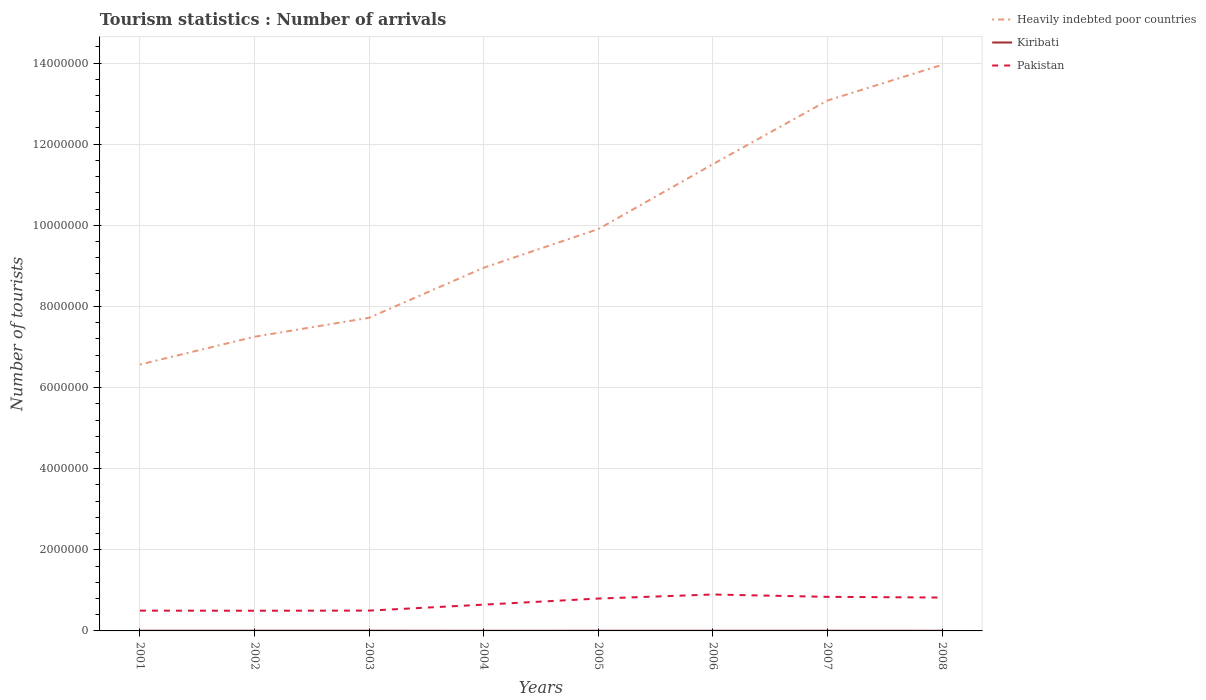How many different coloured lines are there?
Provide a succinct answer. 3. Does the line corresponding to Heavily indebted poor countries intersect with the line corresponding to Kiribati?
Offer a terse response. No. Is the number of lines equal to the number of legend labels?
Provide a short and direct response. Yes. Across all years, what is the maximum number of tourist arrivals in Kiribati?
Your answer should be very brief. 3400. What is the total number of tourist arrivals in Pakistan in the graph?
Your answer should be very brief. -1000. What is the difference between the highest and the second highest number of tourist arrivals in Heavily indebted poor countries?
Provide a short and direct response. 7.39e+06. What is the difference between the highest and the lowest number of tourist arrivals in Kiribati?
Provide a short and direct response. 5. Is the number of tourist arrivals in Kiribati strictly greater than the number of tourist arrivals in Pakistan over the years?
Keep it short and to the point. Yes. How many years are there in the graph?
Give a very brief answer. 8. Are the values on the major ticks of Y-axis written in scientific E-notation?
Your answer should be compact. No. Does the graph contain any zero values?
Offer a terse response. No. How many legend labels are there?
Your response must be concise. 3. How are the legend labels stacked?
Provide a short and direct response. Vertical. What is the title of the graph?
Your response must be concise. Tourism statistics : Number of arrivals. What is the label or title of the Y-axis?
Provide a succinct answer. Number of tourists. What is the Number of tourists of Heavily indebted poor countries in 2001?
Offer a terse response. 6.57e+06. What is the Number of tourists in Kiribati in 2001?
Your response must be concise. 4600. What is the Number of tourists of Pakistan in 2001?
Offer a terse response. 5.00e+05. What is the Number of tourists of Heavily indebted poor countries in 2002?
Keep it short and to the point. 7.25e+06. What is the Number of tourists of Kiribati in 2002?
Provide a short and direct response. 4900. What is the Number of tourists in Pakistan in 2002?
Offer a terse response. 4.98e+05. What is the Number of tourists of Heavily indebted poor countries in 2003?
Offer a very short reply. 7.72e+06. What is the Number of tourists in Kiribati in 2003?
Keep it short and to the point. 4900. What is the Number of tourists of Pakistan in 2003?
Provide a succinct answer. 5.01e+05. What is the Number of tourists in Heavily indebted poor countries in 2004?
Provide a succinct answer. 8.95e+06. What is the Number of tourists in Kiribati in 2004?
Keep it short and to the point. 3400. What is the Number of tourists in Pakistan in 2004?
Offer a very short reply. 6.48e+05. What is the Number of tourists in Heavily indebted poor countries in 2005?
Your answer should be very brief. 9.91e+06. What is the Number of tourists in Kiribati in 2005?
Make the answer very short. 4100. What is the Number of tourists in Pakistan in 2005?
Give a very brief answer. 7.98e+05. What is the Number of tourists of Heavily indebted poor countries in 2006?
Offer a very short reply. 1.15e+07. What is the Number of tourists of Kiribati in 2006?
Your answer should be very brief. 4400. What is the Number of tourists of Pakistan in 2006?
Give a very brief answer. 8.98e+05. What is the Number of tourists in Heavily indebted poor countries in 2007?
Offer a terse response. 1.31e+07. What is the Number of tourists in Kiribati in 2007?
Offer a terse response. 4700. What is the Number of tourists of Pakistan in 2007?
Ensure brevity in your answer.  8.40e+05. What is the Number of tourists in Heavily indebted poor countries in 2008?
Keep it short and to the point. 1.40e+07. What is the Number of tourists of Kiribati in 2008?
Offer a very short reply. 3900. What is the Number of tourists of Pakistan in 2008?
Provide a succinct answer. 8.23e+05. Across all years, what is the maximum Number of tourists of Heavily indebted poor countries?
Your answer should be compact. 1.40e+07. Across all years, what is the maximum Number of tourists of Kiribati?
Give a very brief answer. 4900. Across all years, what is the maximum Number of tourists of Pakistan?
Give a very brief answer. 8.98e+05. Across all years, what is the minimum Number of tourists of Heavily indebted poor countries?
Your answer should be very brief. 6.57e+06. Across all years, what is the minimum Number of tourists in Kiribati?
Provide a short and direct response. 3400. Across all years, what is the minimum Number of tourists of Pakistan?
Your answer should be very brief. 4.98e+05. What is the total Number of tourists in Heavily indebted poor countries in the graph?
Provide a short and direct response. 7.89e+07. What is the total Number of tourists in Kiribati in the graph?
Make the answer very short. 3.49e+04. What is the total Number of tourists in Pakistan in the graph?
Your answer should be compact. 5.51e+06. What is the difference between the Number of tourists in Heavily indebted poor countries in 2001 and that in 2002?
Provide a succinct answer. -6.84e+05. What is the difference between the Number of tourists of Kiribati in 2001 and that in 2002?
Offer a terse response. -300. What is the difference between the Number of tourists in Pakistan in 2001 and that in 2002?
Ensure brevity in your answer.  2000. What is the difference between the Number of tourists in Heavily indebted poor countries in 2001 and that in 2003?
Your answer should be very brief. -1.15e+06. What is the difference between the Number of tourists of Kiribati in 2001 and that in 2003?
Ensure brevity in your answer.  -300. What is the difference between the Number of tourists of Pakistan in 2001 and that in 2003?
Your answer should be compact. -1000. What is the difference between the Number of tourists of Heavily indebted poor countries in 2001 and that in 2004?
Give a very brief answer. -2.39e+06. What is the difference between the Number of tourists of Kiribati in 2001 and that in 2004?
Give a very brief answer. 1200. What is the difference between the Number of tourists in Pakistan in 2001 and that in 2004?
Provide a short and direct response. -1.48e+05. What is the difference between the Number of tourists in Heavily indebted poor countries in 2001 and that in 2005?
Make the answer very short. -3.34e+06. What is the difference between the Number of tourists in Pakistan in 2001 and that in 2005?
Your response must be concise. -2.98e+05. What is the difference between the Number of tourists of Heavily indebted poor countries in 2001 and that in 2006?
Your answer should be compact. -4.94e+06. What is the difference between the Number of tourists in Kiribati in 2001 and that in 2006?
Provide a succinct answer. 200. What is the difference between the Number of tourists in Pakistan in 2001 and that in 2006?
Your answer should be very brief. -3.98e+05. What is the difference between the Number of tourists of Heavily indebted poor countries in 2001 and that in 2007?
Keep it short and to the point. -6.51e+06. What is the difference between the Number of tourists in Kiribati in 2001 and that in 2007?
Provide a short and direct response. -100. What is the difference between the Number of tourists in Heavily indebted poor countries in 2001 and that in 2008?
Offer a terse response. -7.39e+06. What is the difference between the Number of tourists of Kiribati in 2001 and that in 2008?
Provide a short and direct response. 700. What is the difference between the Number of tourists of Pakistan in 2001 and that in 2008?
Give a very brief answer. -3.23e+05. What is the difference between the Number of tourists of Heavily indebted poor countries in 2002 and that in 2003?
Give a very brief answer. -4.68e+05. What is the difference between the Number of tourists of Pakistan in 2002 and that in 2003?
Your answer should be very brief. -3000. What is the difference between the Number of tourists in Heavily indebted poor countries in 2002 and that in 2004?
Make the answer very short. -1.70e+06. What is the difference between the Number of tourists in Kiribati in 2002 and that in 2004?
Offer a terse response. 1500. What is the difference between the Number of tourists of Heavily indebted poor countries in 2002 and that in 2005?
Make the answer very short. -2.65e+06. What is the difference between the Number of tourists in Kiribati in 2002 and that in 2005?
Your answer should be very brief. 800. What is the difference between the Number of tourists in Pakistan in 2002 and that in 2005?
Your response must be concise. -3.00e+05. What is the difference between the Number of tourists of Heavily indebted poor countries in 2002 and that in 2006?
Offer a terse response. -4.25e+06. What is the difference between the Number of tourists of Kiribati in 2002 and that in 2006?
Give a very brief answer. 500. What is the difference between the Number of tourists of Pakistan in 2002 and that in 2006?
Provide a succinct answer. -4.00e+05. What is the difference between the Number of tourists in Heavily indebted poor countries in 2002 and that in 2007?
Your answer should be compact. -5.82e+06. What is the difference between the Number of tourists of Pakistan in 2002 and that in 2007?
Give a very brief answer. -3.42e+05. What is the difference between the Number of tourists in Heavily indebted poor countries in 2002 and that in 2008?
Your answer should be compact. -6.70e+06. What is the difference between the Number of tourists in Kiribati in 2002 and that in 2008?
Keep it short and to the point. 1000. What is the difference between the Number of tourists of Pakistan in 2002 and that in 2008?
Offer a terse response. -3.25e+05. What is the difference between the Number of tourists in Heavily indebted poor countries in 2003 and that in 2004?
Offer a terse response. -1.23e+06. What is the difference between the Number of tourists in Kiribati in 2003 and that in 2004?
Offer a terse response. 1500. What is the difference between the Number of tourists of Pakistan in 2003 and that in 2004?
Provide a succinct answer. -1.47e+05. What is the difference between the Number of tourists of Heavily indebted poor countries in 2003 and that in 2005?
Ensure brevity in your answer.  -2.19e+06. What is the difference between the Number of tourists of Kiribati in 2003 and that in 2005?
Offer a terse response. 800. What is the difference between the Number of tourists of Pakistan in 2003 and that in 2005?
Provide a succinct answer. -2.97e+05. What is the difference between the Number of tourists in Heavily indebted poor countries in 2003 and that in 2006?
Make the answer very short. -3.79e+06. What is the difference between the Number of tourists of Kiribati in 2003 and that in 2006?
Your answer should be compact. 500. What is the difference between the Number of tourists of Pakistan in 2003 and that in 2006?
Provide a short and direct response. -3.97e+05. What is the difference between the Number of tourists in Heavily indebted poor countries in 2003 and that in 2007?
Provide a succinct answer. -5.36e+06. What is the difference between the Number of tourists in Pakistan in 2003 and that in 2007?
Your answer should be very brief. -3.39e+05. What is the difference between the Number of tourists in Heavily indebted poor countries in 2003 and that in 2008?
Ensure brevity in your answer.  -6.23e+06. What is the difference between the Number of tourists in Kiribati in 2003 and that in 2008?
Give a very brief answer. 1000. What is the difference between the Number of tourists in Pakistan in 2003 and that in 2008?
Ensure brevity in your answer.  -3.22e+05. What is the difference between the Number of tourists in Heavily indebted poor countries in 2004 and that in 2005?
Offer a very short reply. -9.53e+05. What is the difference between the Number of tourists of Kiribati in 2004 and that in 2005?
Offer a very short reply. -700. What is the difference between the Number of tourists in Pakistan in 2004 and that in 2005?
Give a very brief answer. -1.50e+05. What is the difference between the Number of tourists of Heavily indebted poor countries in 2004 and that in 2006?
Your response must be concise. -2.55e+06. What is the difference between the Number of tourists of Kiribati in 2004 and that in 2006?
Keep it short and to the point. -1000. What is the difference between the Number of tourists of Heavily indebted poor countries in 2004 and that in 2007?
Your answer should be very brief. -4.12e+06. What is the difference between the Number of tourists of Kiribati in 2004 and that in 2007?
Provide a succinct answer. -1300. What is the difference between the Number of tourists in Pakistan in 2004 and that in 2007?
Your response must be concise. -1.92e+05. What is the difference between the Number of tourists in Heavily indebted poor countries in 2004 and that in 2008?
Your response must be concise. -5.00e+06. What is the difference between the Number of tourists of Kiribati in 2004 and that in 2008?
Ensure brevity in your answer.  -500. What is the difference between the Number of tourists of Pakistan in 2004 and that in 2008?
Your answer should be compact. -1.75e+05. What is the difference between the Number of tourists of Heavily indebted poor countries in 2005 and that in 2006?
Provide a succinct answer. -1.60e+06. What is the difference between the Number of tourists of Kiribati in 2005 and that in 2006?
Give a very brief answer. -300. What is the difference between the Number of tourists of Pakistan in 2005 and that in 2006?
Give a very brief answer. -1.00e+05. What is the difference between the Number of tourists in Heavily indebted poor countries in 2005 and that in 2007?
Give a very brief answer. -3.17e+06. What is the difference between the Number of tourists in Kiribati in 2005 and that in 2007?
Provide a short and direct response. -600. What is the difference between the Number of tourists in Pakistan in 2005 and that in 2007?
Your answer should be compact. -4.20e+04. What is the difference between the Number of tourists in Heavily indebted poor countries in 2005 and that in 2008?
Keep it short and to the point. -4.05e+06. What is the difference between the Number of tourists in Kiribati in 2005 and that in 2008?
Provide a short and direct response. 200. What is the difference between the Number of tourists in Pakistan in 2005 and that in 2008?
Ensure brevity in your answer.  -2.50e+04. What is the difference between the Number of tourists of Heavily indebted poor countries in 2006 and that in 2007?
Offer a very short reply. -1.57e+06. What is the difference between the Number of tourists in Kiribati in 2006 and that in 2007?
Your answer should be compact. -300. What is the difference between the Number of tourists in Pakistan in 2006 and that in 2007?
Provide a succinct answer. 5.80e+04. What is the difference between the Number of tourists in Heavily indebted poor countries in 2006 and that in 2008?
Ensure brevity in your answer.  -2.45e+06. What is the difference between the Number of tourists of Kiribati in 2006 and that in 2008?
Your response must be concise. 500. What is the difference between the Number of tourists of Pakistan in 2006 and that in 2008?
Your answer should be compact. 7.50e+04. What is the difference between the Number of tourists in Heavily indebted poor countries in 2007 and that in 2008?
Provide a short and direct response. -8.78e+05. What is the difference between the Number of tourists in Kiribati in 2007 and that in 2008?
Ensure brevity in your answer.  800. What is the difference between the Number of tourists in Pakistan in 2007 and that in 2008?
Ensure brevity in your answer.  1.70e+04. What is the difference between the Number of tourists of Heavily indebted poor countries in 2001 and the Number of tourists of Kiribati in 2002?
Offer a very short reply. 6.56e+06. What is the difference between the Number of tourists in Heavily indebted poor countries in 2001 and the Number of tourists in Pakistan in 2002?
Your answer should be very brief. 6.07e+06. What is the difference between the Number of tourists in Kiribati in 2001 and the Number of tourists in Pakistan in 2002?
Your answer should be compact. -4.93e+05. What is the difference between the Number of tourists of Heavily indebted poor countries in 2001 and the Number of tourists of Kiribati in 2003?
Offer a very short reply. 6.56e+06. What is the difference between the Number of tourists of Heavily indebted poor countries in 2001 and the Number of tourists of Pakistan in 2003?
Give a very brief answer. 6.07e+06. What is the difference between the Number of tourists of Kiribati in 2001 and the Number of tourists of Pakistan in 2003?
Your response must be concise. -4.96e+05. What is the difference between the Number of tourists of Heavily indebted poor countries in 2001 and the Number of tourists of Kiribati in 2004?
Give a very brief answer. 6.56e+06. What is the difference between the Number of tourists of Heavily indebted poor countries in 2001 and the Number of tourists of Pakistan in 2004?
Keep it short and to the point. 5.92e+06. What is the difference between the Number of tourists in Kiribati in 2001 and the Number of tourists in Pakistan in 2004?
Provide a short and direct response. -6.43e+05. What is the difference between the Number of tourists in Heavily indebted poor countries in 2001 and the Number of tourists in Kiribati in 2005?
Provide a short and direct response. 6.56e+06. What is the difference between the Number of tourists of Heavily indebted poor countries in 2001 and the Number of tourists of Pakistan in 2005?
Give a very brief answer. 5.77e+06. What is the difference between the Number of tourists of Kiribati in 2001 and the Number of tourists of Pakistan in 2005?
Keep it short and to the point. -7.93e+05. What is the difference between the Number of tourists of Heavily indebted poor countries in 2001 and the Number of tourists of Kiribati in 2006?
Your response must be concise. 6.56e+06. What is the difference between the Number of tourists in Heavily indebted poor countries in 2001 and the Number of tourists in Pakistan in 2006?
Keep it short and to the point. 5.67e+06. What is the difference between the Number of tourists in Kiribati in 2001 and the Number of tourists in Pakistan in 2006?
Offer a terse response. -8.93e+05. What is the difference between the Number of tourists of Heavily indebted poor countries in 2001 and the Number of tourists of Kiribati in 2007?
Your answer should be compact. 6.56e+06. What is the difference between the Number of tourists in Heavily indebted poor countries in 2001 and the Number of tourists in Pakistan in 2007?
Provide a succinct answer. 5.73e+06. What is the difference between the Number of tourists in Kiribati in 2001 and the Number of tourists in Pakistan in 2007?
Offer a very short reply. -8.35e+05. What is the difference between the Number of tourists of Heavily indebted poor countries in 2001 and the Number of tourists of Kiribati in 2008?
Ensure brevity in your answer.  6.56e+06. What is the difference between the Number of tourists of Heavily indebted poor countries in 2001 and the Number of tourists of Pakistan in 2008?
Your answer should be compact. 5.75e+06. What is the difference between the Number of tourists in Kiribati in 2001 and the Number of tourists in Pakistan in 2008?
Your response must be concise. -8.18e+05. What is the difference between the Number of tourists of Heavily indebted poor countries in 2002 and the Number of tourists of Kiribati in 2003?
Your answer should be compact. 7.25e+06. What is the difference between the Number of tourists of Heavily indebted poor countries in 2002 and the Number of tourists of Pakistan in 2003?
Your answer should be compact. 6.75e+06. What is the difference between the Number of tourists of Kiribati in 2002 and the Number of tourists of Pakistan in 2003?
Provide a short and direct response. -4.96e+05. What is the difference between the Number of tourists in Heavily indebted poor countries in 2002 and the Number of tourists in Kiribati in 2004?
Make the answer very short. 7.25e+06. What is the difference between the Number of tourists in Heavily indebted poor countries in 2002 and the Number of tourists in Pakistan in 2004?
Offer a very short reply. 6.60e+06. What is the difference between the Number of tourists in Kiribati in 2002 and the Number of tourists in Pakistan in 2004?
Offer a terse response. -6.43e+05. What is the difference between the Number of tourists of Heavily indebted poor countries in 2002 and the Number of tourists of Kiribati in 2005?
Offer a terse response. 7.25e+06. What is the difference between the Number of tourists in Heavily indebted poor countries in 2002 and the Number of tourists in Pakistan in 2005?
Ensure brevity in your answer.  6.45e+06. What is the difference between the Number of tourists of Kiribati in 2002 and the Number of tourists of Pakistan in 2005?
Your answer should be very brief. -7.93e+05. What is the difference between the Number of tourists of Heavily indebted poor countries in 2002 and the Number of tourists of Kiribati in 2006?
Offer a terse response. 7.25e+06. What is the difference between the Number of tourists of Heavily indebted poor countries in 2002 and the Number of tourists of Pakistan in 2006?
Keep it short and to the point. 6.35e+06. What is the difference between the Number of tourists of Kiribati in 2002 and the Number of tourists of Pakistan in 2006?
Provide a succinct answer. -8.93e+05. What is the difference between the Number of tourists in Heavily indebted poor countries in 2002 and the Number of tourists in Kiribati in 2007?
Keep it short and to the point. 7.25e+06. What is the difference between the Number of tourists of Heavily indebted poor countries in 2002 and the Number of tourists of Pakistan in 2007?
Keep it short and to the point. 6.41e+06. What is the difference between the Number of tourists in Kiribati in 2002 and the Number of tourists in Pakistan in 2007?
Offer a very short reply. -8.35e+05. What is the difference between the Number of tourists in Heavily indebted poor countries in 2002 and the Number of tourists in Kiribati in 2008?
Provide a succinct answer. 7.25e+06. What is the difference between the Number of tourists of Heavily indebted poor countries in 2002 and the Number of tourists of Pakistan in 2008?
Provide a short and direct response. 6.43e+06. What is the difference between the Number of tourists in Kiribati in 2002 and the Number of tourists in Pakistan in 2008?
Keep it short and to the point. -8.18e+05. What is the difference between the Number of tourists in Heavily indebted poor countries in 2003 and the Number of tourists in Kiribati in 2004?
Make the answer very short. 7.72e+06. What is the difference between the Number of tourists of Heavily indebted poor countries in 2003 and the Number of tourists of Pakistan in 2004?
Offer a terse response. 7.07e+06. What is the difference between the Number of tourists of Kiribati in 2003 and the Number of tourists of Pakistan in 2004?
Make the answer very short. -6.43e+05. What is the difference between the Number of tourists in Heavily indebted poor countries in 2003 and the Number of tourists in Kiribati in 2005?
Your response must be concise. 7.72e+06. What is the difference between the Number of tourists in Heavily indebted poor countries in 2003 and the Number of tourists in Pakistan in 2005?
Your answer should be very brief. 6.92e+06. What is the difference between the Number of tourists in Kiribati in 2003 and the Number of tourists in Pakistan in 2005?
Keep it short and to the point. -7.93e+05. What is the difference between the Number of tourists in Heavily indebted poor countries in 2003 and the Number of tourists in Kiribati in 2006?
Your answer should be very brief. 7.72e+06. What is the difference between the Number of tourists in Heavily indebted poor countries in 2003 and the Number of tourists in Pakistan in 2006?
Make the answer very short. 6.82e+06. What is the difference between the Number of tourists in Kiribati in 2003 and the Number of tourists in Pakistan in 2006?
Your answer should be compact. -8.93e+05. What is the difference between the Number of tourists of Heavily indebted poor countries in 2003 and the Number of tourists of Kiribati in 2007?
Your answer should be compact. 7.72e+06. What is the difference between the Number of tourists in Heavily indebted poor countries in 2003 and the Number of tourists in Pakistan in 2007?
Your response must be concise. 6.88e+06. What is the difference between the Number of tourists in Kiribati in 2003 and the Number of tourists in Pakistan in 2007?
Offer a terse response. -8.35e+05. What is the difference between the Number of tourists in Heavily indebted poor countries in 2003 and the Number of tourists in Kiribati in 2008?
Give a very brief answer. 7.72e+06. What is the difference between the Number of tourists of Heavily indebted poor countries in 2003 and the Number of tourists of Pakistan in 2008?
Your response must be concise. 6.90e+06. What is the difference between the Number of tourists of Kiribati in 2003 and the Number of tourists of Pakistan in 2008?
Offer a terse response. -8.18e+05. What is the difference between the Number of tourists of Heavily indebted poor countries in 2004 and the Number of tourists of Kiribati in 2005?
Provide a short and direct response. 8.95e+06. What is the difference between the Number of tourists of Heavily indebted poor countries in 2004 and the Number of tourists of Pakistan in 2005?
Keep it short and to the point. 8.16e+06. What is the difference between the Number of tourists in Kiribati in 2004 and the Number of tourists in Pakistan in 2005?
Your response must be concise. -7.95e+05. What is the difference between the Number of tourists in Heavily indebted poor countries in 2004 and the Number of tourists in Kiribati in 2006?
Keep it short and to the point. 8.95e+06. What is the difference between the Number of tourists of Heavily indebted poor countries in 2004 and the Number of tourists of Pakistan in 2006?
Your response must be concise. 8.06e+06. What is the difference between the Number of tourists of Kiribati in 2004 and the Number of tourists of Pakistan in 2006?
Provide a short and direct response. -8.95e+05. What is the difference between the Number of tourists in Heavily indebted poor countries in 2004 and the Number of tourists in Kiribati in 2007?
Make the answer very short. 8.95e+06. What is the difference between the Number of tourists in Heavily indebted poor countries in 2004 and the Number of tourists in Pakistan in 2007?
Your answer should be very brief. 8.11e+06. What is the difference between the Number of tourists of Kiribati in 2004 and the Number of tourists of Pakistan in 2007?
Offer a very short reply. -8.37e+05. What is the difference between the Number of tourists in Heavily indebted poor countries in 2004 and the Number of tourists in Kiribati in 2008?
Offer a terse response. 8.95e+06. What is the difference between the Number of tourists of Heavily indebted poor countries in 2004 and the Number of tourists of Pakistan in 2008?
Provide a succinct answer. 8.13e+06. What is the difference between the Number of tourists in Kiribati in 2004 and the Number of tourists in Pakistan in 2008?
Keep it short and to the point. -8.20e+05. What is the difference between the Number of tourists in Heavily indebted poor countries in 2005 and the Number of tourists in Kiribati in 2006?
Keep it short and to the point. 9.90e+06. What is the difference between the Number of tourists in Heavily indebted poor countries in 2005 and the Number of tourists in Pakistan in 2006?
Give a very brief answer. 9.01e+06. What is the difference between the Number of tourists in Kiribati in 2005 and the Number of tourists in Pakistan in 2006?
Provide a succinct answer. -8.94e+05. What is the difference between the Number of tourists in Heavily indebted poor countries in 2005 and the Number of tourists in Kiribati in 2007?
Your answer should be very brief. 9.90e+06. What is the difference between the Number of tourists of Heavily indebted poor countries in 2005 and the Number of tourists of Pakistan in 2007?
Make the answer very short. 9.07e+06. What is the difference between the Number of tourists in Kiribati in 2005 and the Number of tourists in Pakistan in 2007?
Make the answer very short. -8.36e+05. What is the difference between the Number of tourists in Heavily indebted poor countries in 2005 and the Number of tourists in Kiribati in 2008?
Keep it short and to the point. 9.90e+06. What is the difference between the Number of tourists in Heavily indebted poor countries in 2005 and the Number of tourists in Pakistan in 2008?
Your response must be concise. 9.08e+06. What is the difference between the Number of tourists in Kiribati in 2005 and the Number of tourists in Pakistan in 2008?
Offer a terse response. -8.19e+05. What is the difference between the Number of tourists of Heavily indebted poor countries in 2006 and the Number of tourists of Kiribati in 2007?
Give a very brief answer. 1.15e+07. What is the difference between the Number of tourists of Heavily indebted poor countries in 2006 and the Number of tourists of Pakistan in 2007?
Offer a terse response. 1.07e+07. What is the difference between the Number of tourists of Kiribati in 2006 and the Number of tourists of Pakistan in 2007?
Offer a terse response. -8.36e+05. What is the difference between the Number of tourists in Heavily indebted poor countries in 2006 and the Number of tourists in Kiribati in 2008?
Keep it short and to the point. 1.15e+07. What is the difference between the Number of tourists in Heavily indebted poor countries in 2006 and the Number of tourists in Pakistan in 2008?
Ensure brevity in your answer.  1.07e+07. What is the difference between the Number of tourists in Kiribati in 2006 and the Number of tourists in Pakistan in 2008?
Give a very brief answer. -8.19e+05. What is the difference between the Number of tourists of Heavily indebted poor countries in 2007 and the Number of tourists of Kiribati in 2008?
Ensure brevity in your answer.  1.31e+07. What is the difference between the Number of tourists of Heavily indebted poor countries in 2007 and the Number of tourists of Pakistan in 2008?
Your response must be concise. 1.23e+07. What is the difference between the Number of tourists of Kiribati in 2007 and the Number of tourists of Pakistan in 2008?
Offer a very short reply. -8.18e+05. What is the average Number of tourists in Heavily indebted poor countries per year?
Your response must be concise. 9.87e+06. What is the average Number of tourists in Kiribati per year?
Your response must be concise. 4362.5. What is the average Number of tourists in Pakistan per year?
Your response must be concise. 6.88e+05. In the year 2001, what is the difference between the Number of tourists of Heavily indebted poor countries and Number of tourists of Kiribati?
Provide a succinct answer. 6.56e+06. In the year 2001, what is the difference between the Number of tourists of Heavily indebted poor countries and Number of tourists of Pakistan?
Provide a succinct answer. 6.07e+06. In the year 2001, what is the difference between the Number of tourists of Kiribati and Number of tourists of Pakistan?
Ensure brevity in your answer.  -4.95e+05. In the year 2002, what is the difference between the Number of tourists in Heavily indebted poor countries and Number of tourists in Kiribati?
Give a very brief answer. 7.25e+06. In the year 2002, what is the difference between the Number of tourists in Heavily indebted poor countries and Number of tourists in Pakistan?
Your answer should be compact. 6.75e+06. In the year 2002, what is the difference between the Number of tourists in Kiribati and Number of tourists in Pakistan?
Provide a short and direct response. -4.93e+05. In the year 2003, what is the difference between the Number of tourists of Heavily indebted poor countries and Number of tourists of Kiribati?
Your response must be concise. 7.72e+06. In the year 2003, what is the difference between the Number of tourists of Heavily indebted poor countries and Number of tourists of Pakistan?
Make the answer very short. 7.22e+06. In the year 2003, what is the difference between the Number of tourists in Kiribati and Number of tourists in Pakistan?
Offer a terse response. -4.96e+05. In the year 2004, what is the difference between the Number of tourists of Heavily indebted poor countries and Number of tourists of Kiribati?
Provide a short and direct response. 8.95e+06. In the year 2004, what is the difference between the Number of tourists of Heavily indebted poor countries and Number of tourists of Pakistan?
Your response must be concise. 8.31e+06. In the year 2004, what is the difference between the Number of tourists of Kiribati and Number of tourists of Pakistan?
Offer a very short reply. -6.45e+05. In the year 2005, what is the difference between the Number of tourists in Heavily indebted poor countries and Number of tourists in Kiribati?
Make the answer very short. 9.90e+06. In the year 2005, what is the difference between the Number of tourists of Heavily indebted poor countries and Number of tourists of Pakistan?
Your response must be concise. 9.11e+06. In the year 2005, what is the difference between the Number of tourists in Kiribati and Number of tourists in Pakistan?
Give a very brief answer. -7.94e+05. In the year 2006, what is the difference between the Number of tourists of Heavily indebted poor countries and Number of tourists of Kiribati?
Your response must be concise. 1.15e+07. In the year 2006, what is the difference between the Number of tourists in Heavily indebted poor countries and Number of tourists in Pakistan?
Provide a succinct answer. 1.06e+07. In the year 2006, what is the difference between the Number of tourists in Kiribati and Number of tourists in Pakistan?
Offer a very short reply. -8.94e+05. In the year 2007, what is the difference between the Number of tourists in Heavily indebted poor countries and Number of tourists in Kiribati?
Your answer should be compact. 1.31e+07. In the year 2007, what is the difference between the Number of tourists of Heavily indebted poor countries and Number of tourists of Pakistan?
Ensure brevity in your answer.  1.22e+07. In the year 2007, what is the difference between the Number of tourists of Kiribati and Number of tourists of Pakistan?
Offer a very short reply. -8.35e+05. In the year 2008, what is the difference between the Number of tourists of Heavily indebted poor countries and Number of tourists of Kiribati?
Your answer should be compact. 1.40e+07. In the year 2008, what is the difference between the Number of tourists in Heavily indebted poor countries and Number of tourists in Pakistan?
Provide a succinct answer. 1.31e+07. In the year 2008, what is the difference between the Number of tourists of Kiribati and Number of tourists of Pakistan?
Give a very brief answer. -8.19e+05. What is the ratio of the Number of tourists in Heavily indebted poor countries in 2001 to that in 2002?
Provide a short and direct response. 0.91. What is the ratio of the Number of tourists of Kiribati in 2001 to that in 2002?
Keep it short and to the point. 0.94. What is the ratio of the Number of tourists of Heavily indebted poor countries in 2001 to that in 2003?
Offer a terse response. 0.85. What is the ratio of the Number of tourists of Kiribati in 2001 to that in 2003?
Give a very brief answer. 0.94. What is the ratio of the Number of tourists in Heavily indebted poor countries in 2001 to that in 2004?
Give a very brief answer. 0.73. What is the ratio of the Number of tourists in Kiribati in 2001 to that in 2004?
Your answer should be very brief. 1.35. What is the ratio of the Number of tourists in Pakistan in 2001 to that in 2004?
Keep it short and to the point. 0.77. What is the ratio of the Number of tourists of Heavily indebted poor countries in 2001 to that in 2005?
Make the answer very short. 0.66. What is the ratio of the Number of tourists in Kiribati in 2001 to that in 2005?
Keep it short and to the point. 1.12. What is the ratio of the Number of tourists in Pakistan in 2001 to that in 2005?
Make the answer very short. 0.63. What is the ratio of the Number of tourists of Heavily indebted poor countries in 2001 to that in 2006?
Keep it short and to the point. 0.57. What is the ratio of the Number of tourists of Kiribati in 2001 to that in 2006?
Provide a short and direct response. 1.05. What is the ratio of the Number of tourists of Pakistan in 2001 to that in 2006?
Ensure brevity in your answer.  0.56. What is the ratio of the Number of tourists in Heavily indebted poor countries in 2001 to that in 2007?
Offer a very short reply. 0.5. What is the ratio of the Number of tourists of Kiribati in 2001 to that in 2007?
Your response must be concise. 0.98. What is the ratio of the Number of tourists of Pakistan in 2001 to that in 2007?
Your answer should be compact. 0.6. What is the ratio of the Number of tourists of Heavily indebted poor countries in 2001 to that in 2008?
Offer a very short reply. 0.47. What is the ratio of the Number of tourists of Kiribati in 2001 to that in 2008?
Your answer should be very brief. 1.18. What is the ratio of the Number of tourists in Pakistan in 2001 to that in 2008?
Offer a very short reply. 0.61. What is the ratio of the Number of tourists in Heavily indebted poor countries in 2002 to that in 2003?
Your answer should be compact. 0.94. What is the ratio of the Number of tourists in Heavily indebted poor countries in 2002 to that in 2004?
Provide a succinct answer. 0.81. What is the ratio of the Number of tourists of Kiribati in 2002 to that in 2004?
Offer a very short reply. 1.44. What is the ratio of the Number of tourists in Pakistan in 2002 to that in 2004?
Your answer should be very brief. 0.77. What is the ratio of the Number of tourists of Heavily indebted poor countries in 2002 to that in 2005?
Provide a succinct answer. 0.73. What is the ratio of the Number of tourists of Kiribati in 2002 to that in 2005?
Offer a terse response. 1.2. What is the ratio of the Number of tourists of Pakistan in 2002 to that in 2005?
Your answer should be compact. 0.62. What is the ratio of the Number of tourists in Heavily indebted poor countries in 2002 to that in 2006?
Offer a terse response. 0.63. What is the ratio of the Number of tourists in Kiribati in 2002 to that in 2006?
Offer a terse response. 1.11. What is the ratio of the Number of tourists of Pakistan in 2002 to that in 2006?
Your answer should be compact. 0.55. What is the ratio of the Number of tourists of Heavily indebted poor countries in 2002 to that in 2007?
Your answer should be compact. 0.55. What is the ratio of the Number of tourists in Kiribati in 2002 to that in 2007?
Offer a terse response. 1.04. What is the ratio of the Number of tourists of Pakistan in 2002 to that in 2007?
Your answer should be very brief. 0.59. What is the ratio of the Number of tourists in Heavily indebted poor countries in 2002 to that in 2008?
Your response must be concise. 0.52. What is the ratio of the Number of tourists in Kiribati in 2002 to that in 2008?
Give a very brief answer. 1.26. What is the ratio of the Number of tourists in Pakistan in 2002 to that in 2008?
Give a very brief answer. 0.61. What is the ratio of the Number of tourists of Heavily indebted poor countries in 2003 to that in 2004?
Provide a short and direct response. 0.86. What is the ratio of the Number of tourists of Kiribati in 2003 to that in 2004?
Offer a terse response. 1.44. What is the ratio of the Number of tourists of Pakistan in 2003 to that in 2004?
Give a very brief answer. 0.77. What is the ratio of the Number of tourists in Heavily indebted poor countries in 2003 to that in 2005?
Give a very brief answer. 0.78. What is the ratio of the Number of tourists in Kiribati in 2003 to that in 2005?
Keep it short and to the point. 1.2. What is the ratio of the Number of tourists in Pakistan in 2003 to that in 2005?
Provide a short and direct response. 0.63. What is the ratio of the Number of tourists in Heavily indebted poor countries in 2003 to that in 2006?
Your response must be concise. 0.67. What is the ratio of the Number of tourists of Kiribati in 2003 to that in 2006?
Make the answer very short. 1.11. What is the ratio of the Number of tourists of Pakistan in 2003 to that in 2006?
Provide a succinct answer. 0.56. What is the ratio of the Number of tourists in Heavily indebted poor countries in 2003 to that in 2007?
Offer a terse response. 0.59. What is the ratio of the Number of tourists of Kiribati in 2003 to that in 2007?
Offer a terse response. 1.04. What is the ratio of the Number of tourists of Pakistan in 2003 to that in 2007?
Your answer should be compact. 0.6. What is the ratio of the Number of tourists in Heavily indebted poor countries in 2003 to that in 2008?
Provide a short and direct response. 0.55. What is the ratio of the Number of tourists of Kiribati in 2003 to that in 2008?
Your answer should be very brief. 1.26. What is the ratio of the Number of tourists in Pakistan in 2003 to that in 2008?
Offer a very short reply. 0.61. What is the ratio of the Number of tourists of Heavily indebted poor countries in 2004 to that in 2005?
Keep it short and to the point. 0.9. What is the ratio of the Number of tourists of Kiribati in 2004 to that in 2005?
Ensure brevity in your answer.  0.83. What is the ratio of the Number of tourists of Pakistan in 2004 to that in 2005?
Ensure brevity in your answer.  0.81. What is the ratio of the Number of tourists in Heavily indebted poor countries in 2004 to that in 2006?
Your answer should be compact. 0.78. What is the ratio of the Number of tourists of Kiribati in 2004 to that in 2006?
Offer a terse response. 0.77. What is the ratio of the Number of tourists of Pakistan in 2004 to that in 2006?
Offer a terse response. 0.72. What is the ratio of the Number of tourists of Heavily indebted poor countries in 2004 to that in 2007?
Provide a succinct answer. 0.68. What is the ratio of the Number of tourists of Kiribati in 2004 to that in 2007?
Give a very brief answer. 0.72. What is the ratio of the Number of tourists of Pakistan in 2004 to that in 2007?
Your answer should be very brief. 0.77. What is the ratio of the Number of tourists in Heavily indebted poor countries in 2004 to that in 2008?
Your response must be concise. 0.64. What is the ratio of the Number of tourists of Kiribati in 2004 to that in 2008?
Keep it short and to the point. 0.87. What is the ratio of the Number of tourists in Pakistan in 2004 to that in 2008?
Offer a terse response. 0.79. What is the ratio of the Number of tourists in Heavily indebted poor countries in 2005 to that in 2006?
Your answer should be very brief. 0.86. What is the ratio of the Number of tourists in Kiribati in 2005 to that in 2006?
Make the answer very short. 0.93. What is the ratio of the Number of tourists of Pakistan in 2005 to that in 2006?
Provide a short and direct response. 0.89. What is the ratio of the Number of tourists of Heavily indebted poor countries in 2005 to that in 2007?
Offer a very short reply. 0.76. What is the ratio of the Number of tourists in Kiribati in 2005 to that in 2007?
Offer a very short reply. 0.87. What is the ratio of the Number of tourists in Heavily indebted poor countries in 2005 to that in 2008?
Ensure brevity in your answer.  0.71. What is the ratio of the Number of tourists in Kiribati in 2005 to that in 2008?
Provide a succinct answer. 1.05. What is the ratio of the Number of tourists in Pakistan in 2005 to that in 2008?
Make the answer very short. 0.97. What is the ratio of the Number of tourists of Heavily indebted poor countries in 2006 to that in 2007?
Provide a succinct answer. 0.88. What is the ratio of the Number of tourists of Kiribati in 2006 to that in 2007?
Offer a terse response. 0.94. What is the ratio of the Number of tourists of Pakistan in 2006 to that in 2007?
Keep it short and to the point. 1.07. What is the ratio of the Number of tourists in Heavily indebted poor countries in 2006 to that in 2008?
Offer a terse response. 0.82. What is the ratio of the Number of tourists in Kiribati in 2006 to that in 2008?
Your answer should be compact. 1.13. What is the ratio of the Number of tourists of Pakistan in 2006 to that in 2008?
Your answer should be very brief. 1.09. What is the ratio of the Number of tourists in Heavily indebted poor countries in 2007 to that in 2008?
Provide a succinct answer. 0.94. What is the ratio of the Number of tourists of Kiribati in 2007 to that in 2008?
Provide a succinct answer. 1.21. What is the ratio of the Number of tourists in Pakistan in 2007 to that in 2008?
Ensure brevity in your answer.  1.02. What is the difference between the highest and the second highest Number of tourists in Heavily indebted poor countries?
Your answer should be compact. 8.78e+05. What is the difference between the highest and the second highest Number of tourists of Kiribati?
Your response must be concise. 0. What is the difference between the highest and the second highest Number of tourists in Pakistan?
Your response must be concise. 5.80e+04. What is the difference between the highest and the lowest Number of tourists in Heavily indebted poor countries?
Provide a succinct answer. 7.39e+06. What is the difference between the highest and the lowest Number of tourists in Kiribati?
Offer a very short reply. 1500. What is the difference between the highest and the lowest Number of tourists of Pakistan?
Keep it short and to the point. 4.00e+05. 